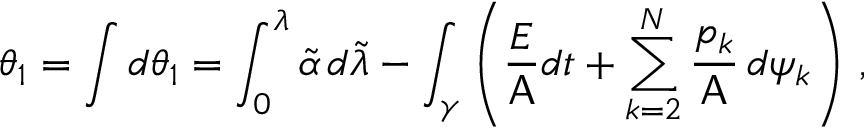<formula> <loc_0><loc_0><loc_500><loc_500>\theta _ { 1 } = \int d \theta _ { 1 } = \int _ { 0 } ^ { \lambda } \widetilde { \alpha } \, d \widetilde { \lambda } - \int _ { \gamma } \left ( \frac { E } { A } d t + \sum _ { k = 2 } ^ { N } \frac { p _ { k } } { A } \, d \psi _ { k } \right ) \, ,</formula> 